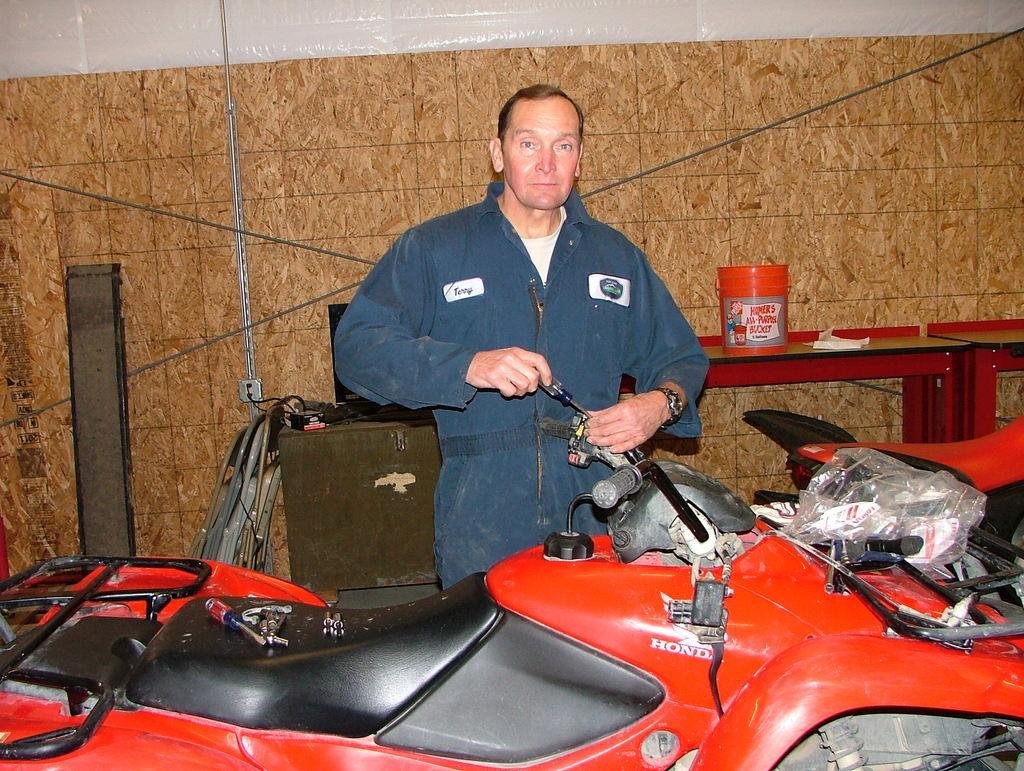In one or two sentences, can you explain what this image depicts? In this picture I can see a vehicle in front which is of red and black color and I see few tools on it. I can also see a man who is holding a tool in his hands. In the background I can see the red color things on which there is a box and a white color thing. On the left side of this picture I can see few more things. 